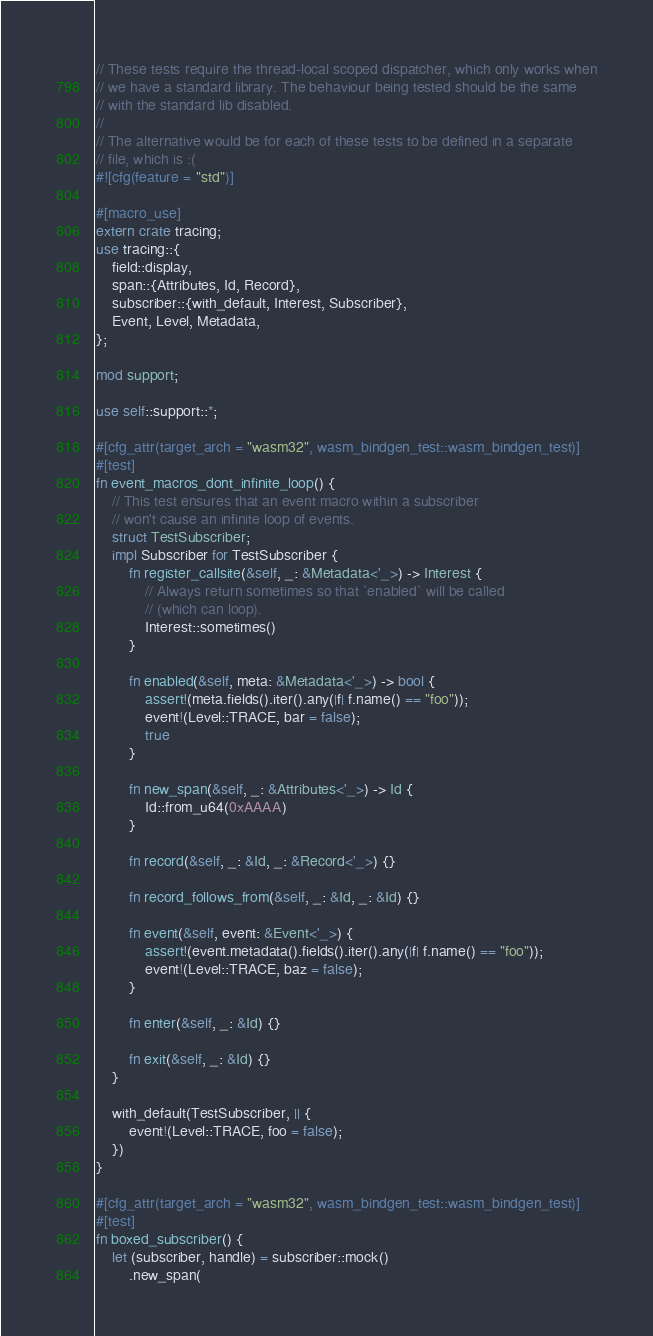<code> <loc_0><loc_0><loc_500><loc_500><_Rust_>// These tests require the thread-local scoped dispatcher, which only works when
// we have a standard library. The behaviour being tested should be the same
// with the standard lib disabled.
//
// The alternative would be for each of these tests to be defined in a separate
// file, which is :(
#![cfg(feature = "std")]

#[macro_use]
extern crate tracing;
use tracing::{
    field::display,
    span::{Attributes, Id, Record},
    subscriber::{with_default, Interest, Subscriber},
    Event, Level, Metadata,
};

mod support;

use self::support::*;

#[cfg_attr(target_arch = "wasm32", wasm_bindgen_test::wasm_bindgen_test)]
#[test]
fn event_macros_dont_infinite_loop() {
    // This test ensures that an event macro within a subscriber
    // won't cause an infinite loop of events.
    struct TestSubscriber;
    impl Subscriber for TestSubscriber {
        fn register_callsite(&self, _: &Metadata<'_>) -> Interest {
            // Always return sometimes so that `enabled` will be called
            // (which can loop).
            Interest::sometimes()
        }

        fn enabled(&self, meta: &Metadata<'_>) -> bool {
            assert!(meta.fields().iter().any(|f| f.name() == "foo"));
            event!(Level::TRACE, bar = false);
            true
        }

        fn new_span(&self, _: &Attributes<'_>) -> Id {
            Id::from_u64(0xAAAA)
        }

        fn record(&self, _: &Id, _: &Record<'_>) {}

        fn record_follows_from(&self, _: &Id, _: &Id) {}

        fn event(&self, event: &Event<'_>) {
            assert!(event.metadata().fields().iter().any(|f| f.name() == "foo"));
            event!(Level::TRACE, baz = false);
        }

        fn enter(&self, _: &Id) {}

        fn exit(&self, _: &Id) {}
    }

    with_default(TestSubscriber, || {
        event!(Level::TRACE, foo = false);
    })
}

#[cfg_attr(target_arch = "wasm32", wasm_bindgen_test::wasm_bindgen_test)]
#[test]
fn boxed_subscriber() {
    let (subscriber, handle) = subscriber::mock()
        .new_span(</code> 